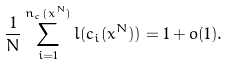<formula> <loc_0><loc_0><loc_500><loc_500>\frac { 1 } { N } \sum _ { i = 1 } ^ { n _ { c } ( x ^ { N } ) } l ( c _ { i } ( x ^ { N } ) ) = 1 + o ( 1 ) .</formula> 